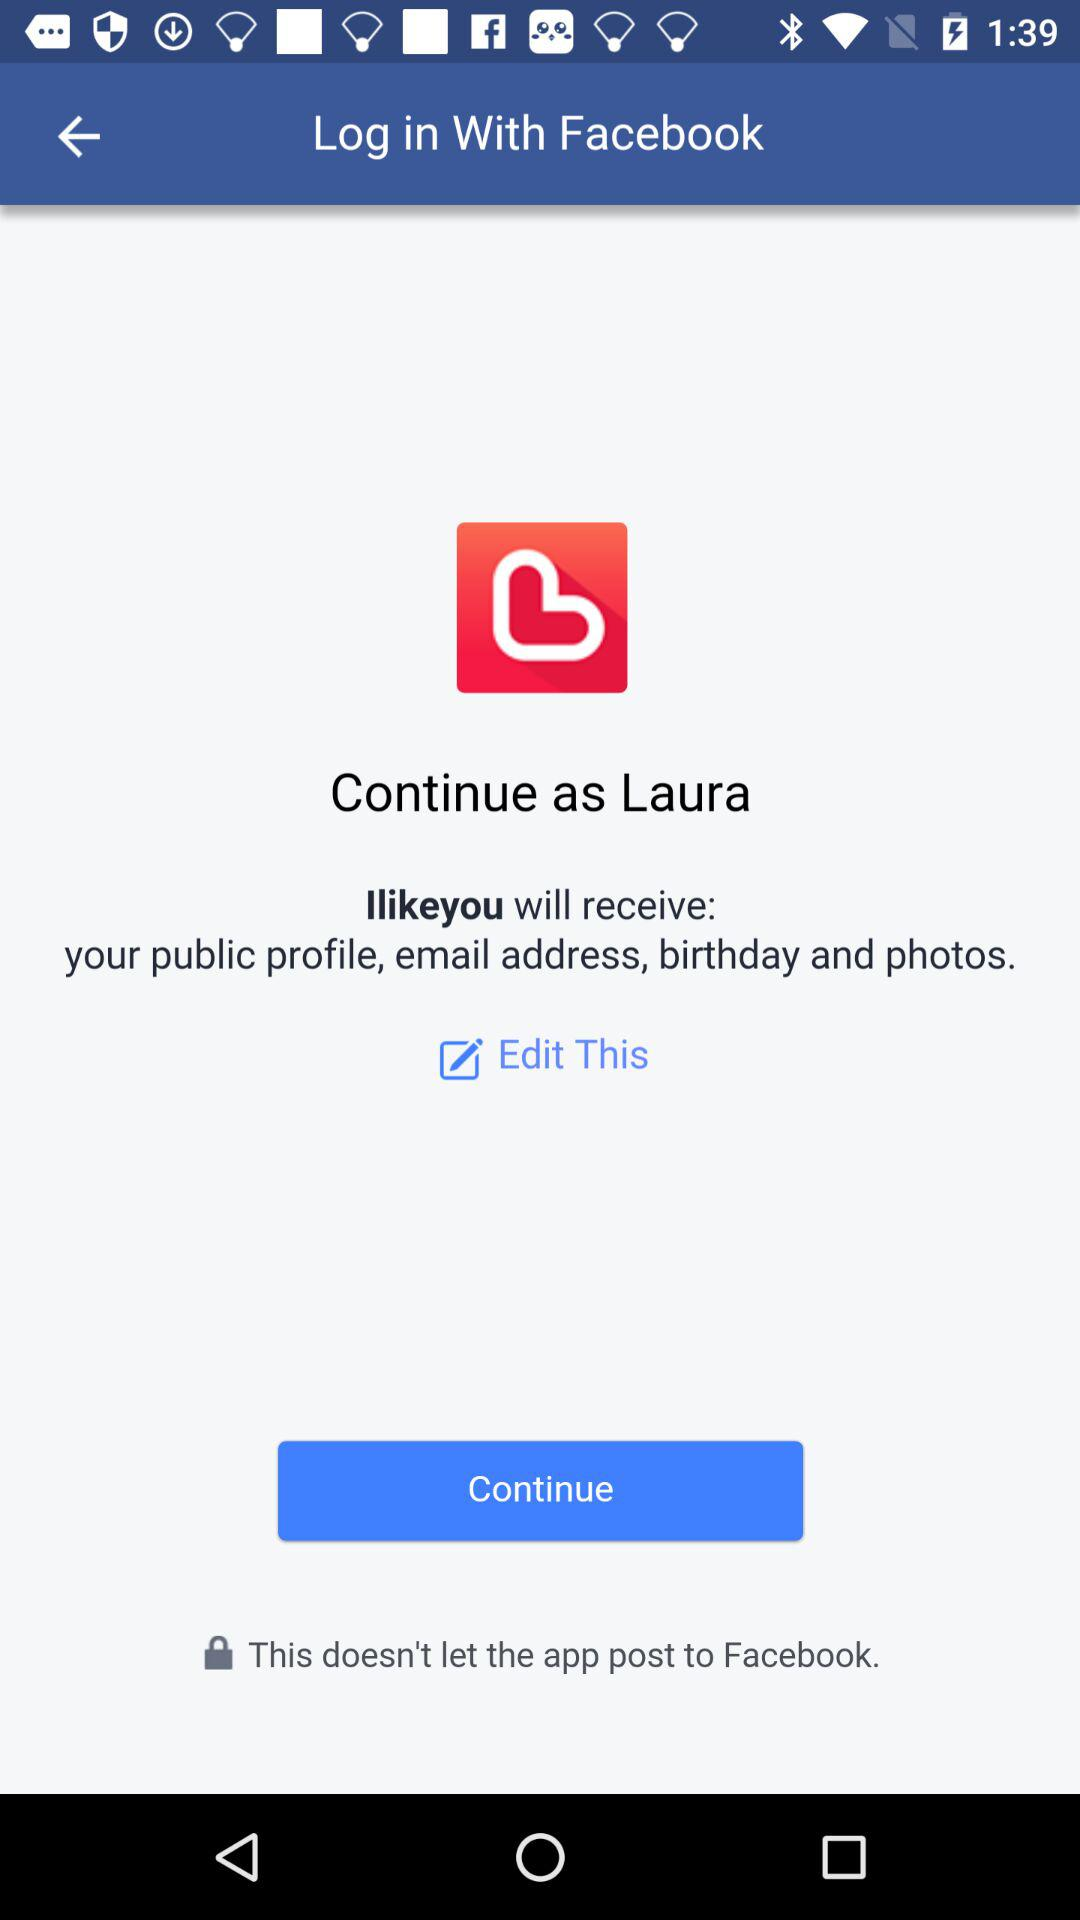What application is asking for permission? The application asking for permission is "Ilikeyou". 